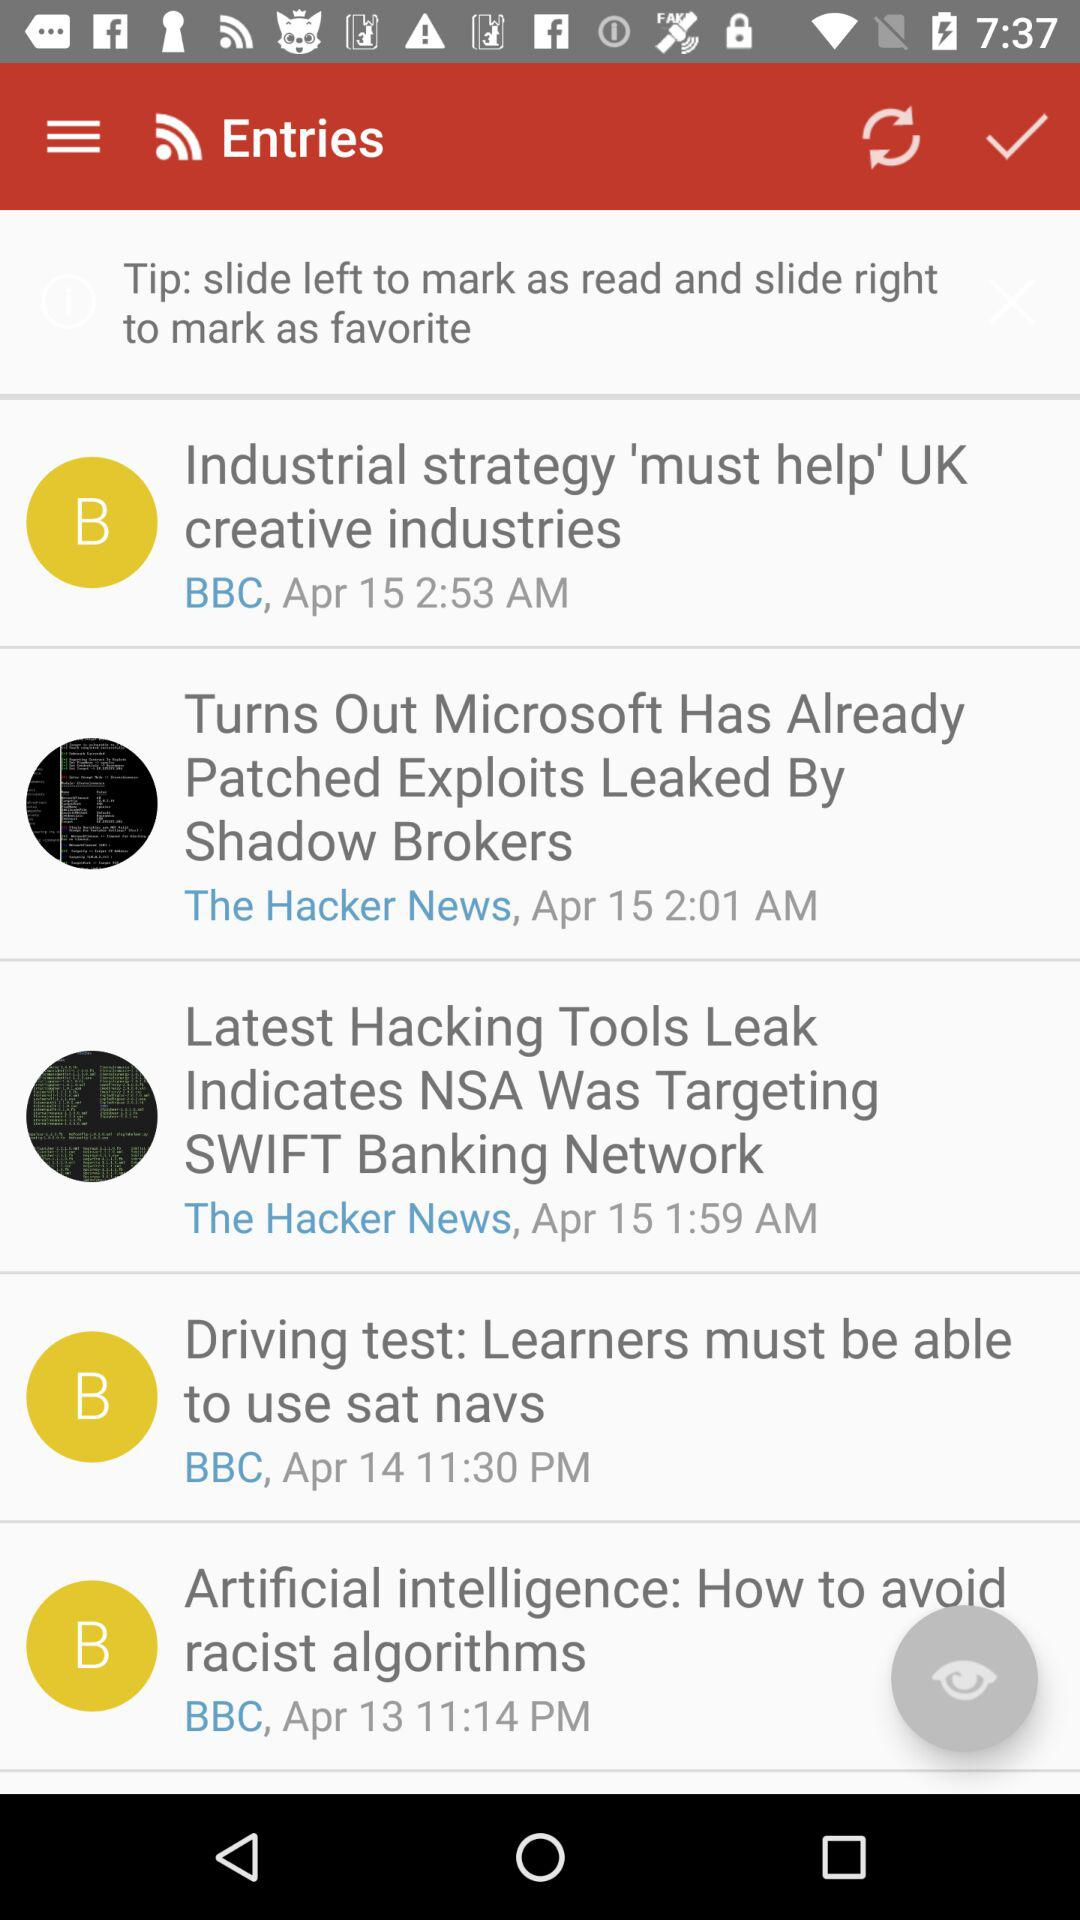What is the time of the entry "Artificial intelligence: How to avoid racist algorithms"? The time is 11:14 p.m. 